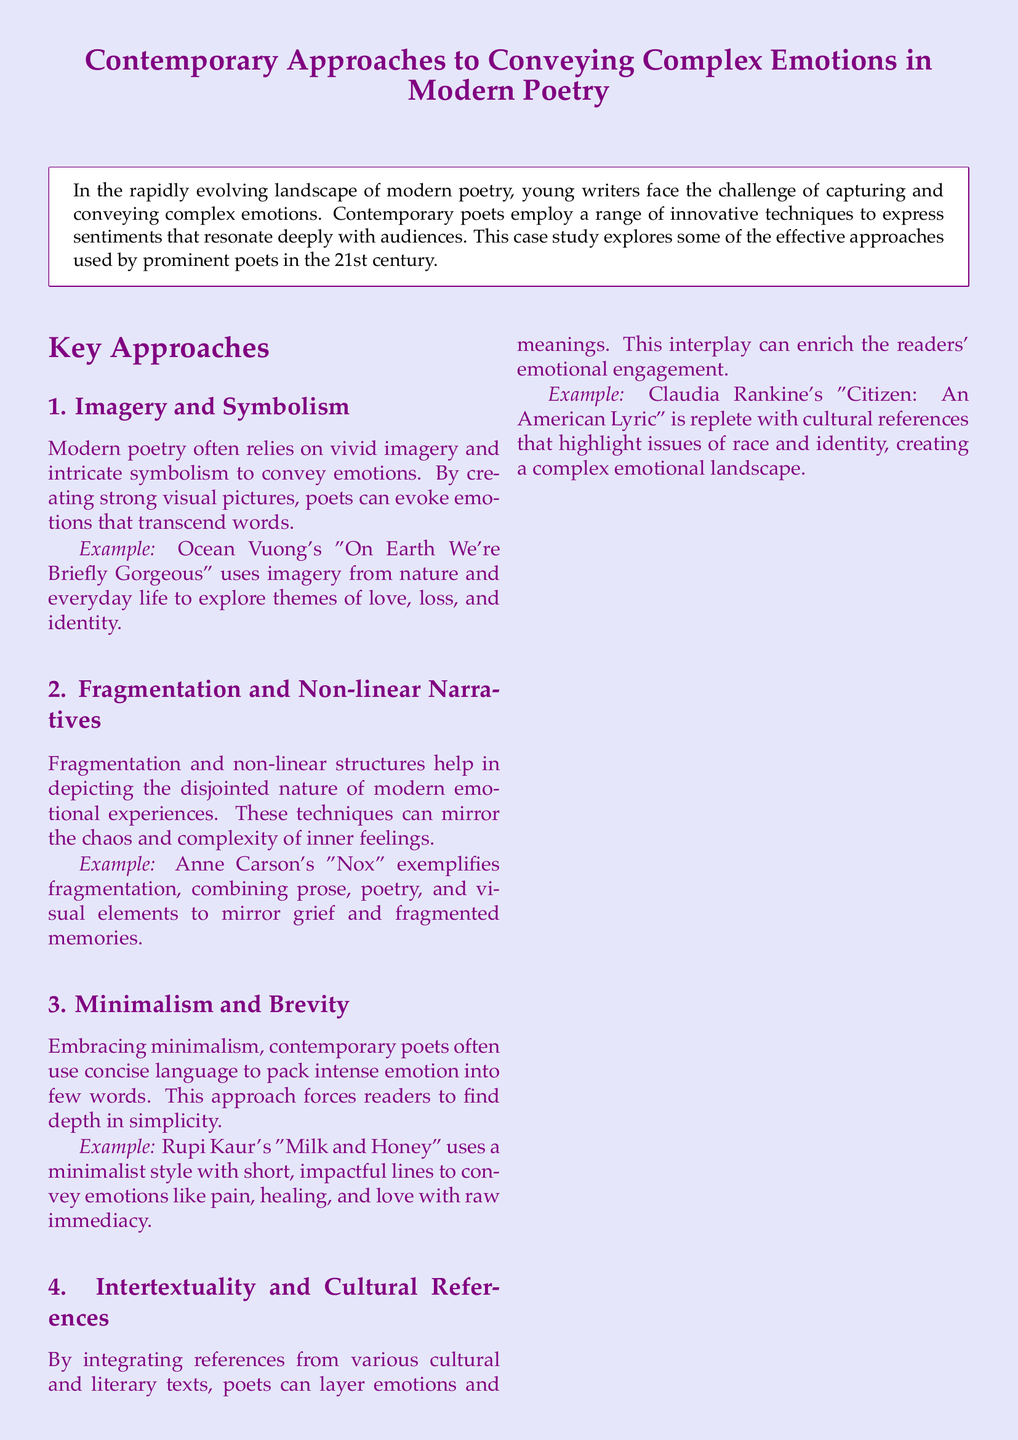What is the title of the case study? The title is provided at the top of the document and reflects the main subject matter, which is about modern poetry.
Answer: Contemporary Approaches to Conveying Complex Emotions in Modern Poetry Who is the author of "On Earth We're Briefly Gorgeous"? This information is located within the examples section and identifies the poet associated with that work.
Answer: Ocean Vuong What technique does Anne Carson employ in "Nox"? This question pertains to the specific approach used in the example provided, combining various elements to express complex emotions.
Answer: Fragmentation What publication year is associated with "Milk and Honey"? The year of publication is included in the references section, identifying when this work was released.
Answer: 2015 How many key approaches are discussed in the case study? The document lays out specific methods for conveying emotions in poetry, which are organized into a distinct count.
Answer: Four What emotion is Rupi Kaur's poetry primarily associated with? This relates to an overarching theme highlighted in the example, detailing the type of emotions expressed in her work.
Answer: Pain Which poet's work is replete with cultural references? This question asks for the specific poet noted in the document for integrating cultural and literary references in their poetry.
Answer: Claudia Rankine What type of structure is mentioned in the context of conveying disjointed emotions? This refers to a specific literary technique that helps represent complex emotional experiences in poetry, mentioned in the key approaches.
Answer: Non-linear Narratives 